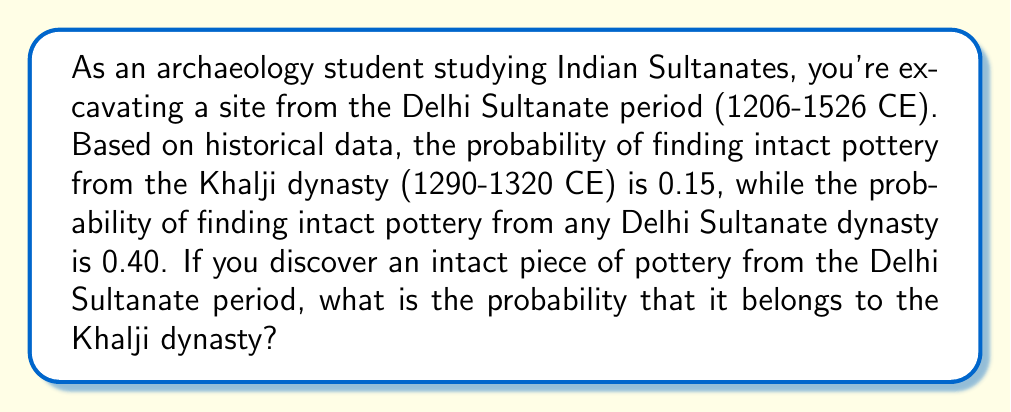Provide a solution to this math problem. To solve this problem, we need to use Bayes' Theorem, which is given by:

$$P(A|B) = \frac{P(B|A) \cdot P(A)}{P(B)}$$

Where:
$A$ = Event of finding Khalji dynasty pottery
$B$ = Event of finding Delhi Sultanate pottery

We are given:
$P(A) = 0.15$ (probability of finding Khalji dynasty pottery)
$P(B) = 0.40$ (probability of finding Delhi Sultanate pottery)
$P(B|A) = 1$ (if we find Khalji pottery, it's definitely from the Delhi Sultanate)

Substituting these values into Bayes' Theorem:

$$P(A|B) = \frac{1 \cdot 0.15}{0.40}$$

$$P(A|B) = \frac{0.15}{0.40}$$

$$P(A|B) = 0.375$$

Therefore, the probability that the intact pottery belongs to the Khalji dynasty, given that it's from the Delhi Sultanate period, is 0.375 or 37.5%.
Answer: The probability that the intact pottery belongs to the Khalji dynasty, given that it's from the Delhi Sultanate period, is $0.375$ or $37.5\%$. 